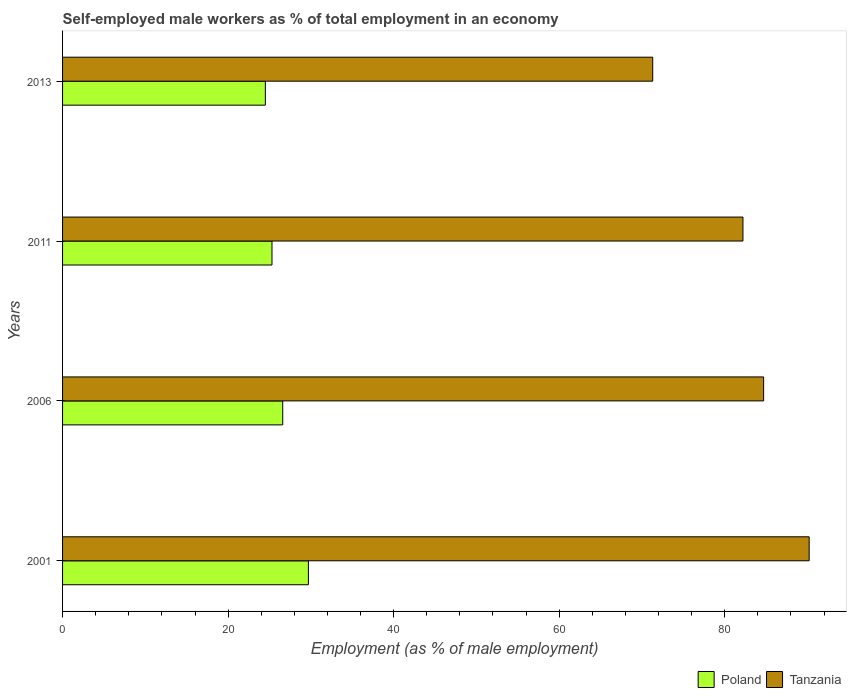Are the number of bars per tick equal to the number of legend labels?
Your answer should be compact. Yes. How many bars are there on the 4th tick from the bottom?
Give a very brief answer. 2. What is the percentage of self-employed male workers in Tanzania in 2011?
Make the answer very short. 82.2. Across all years, what is the maximum percentage of self-employed male workers in Poland?
Offer a very short reply. 29.7. Across all years, what is the minimum percentage of self-employed male workers in Poland?
Your answer should be compact. 24.5. In which year was the percentage of self-employed male workers in Poland maximum?
Provide a short and direct response. 2001. In which year was the percentage of self-employed male workers in Poland minimum?
Offer a very short reply. 2013. What is the total percentage of self-employed male workers in Poland in the graph?
Give a very brief answer. 106.1. What is the difference between the percentage of self-employed male workers in Poland in 2001 and that in 2006?
Give a very brief answer. 3.1. What is the difference between the percentage of self-employed male workers in Tanzania in 2006 and the percentage of self-employed male workers in Poland in 2011?
Offer a very short reply. 59.4. What is the average percentage of self-employed male workers in Tanzania per year?
Provide a short and direct response. 82.1. In the year 2013, what is the difference between the percentage of self-employed male workers in Tanzania and percentage of self-employed male workers in Poland?
Offer a very short reply. 46.8. In how many years, is the percentage of self-employed male workers in Tanzania greater than 56 %?
Your answer should be very brief. 4. What is the ratio of the percentage of self-employed male workers in Poland in 2006 to that in 2011?
Give a very brief answer. 1.05. Is the percentage of self-employed male workers in Tanzania in 2001 less than that in 2013?
Your answer should be very brief. No. What is the difference between the highest and the second highest percentage of self-employed male workers in Poland?
Your answer should be compact. 3.1. What is the difference between the highest and the lowest percentage of self-employed male workers in Poland?
Your answer should be very brief. 5.2. What does the 2nd bar from the top in 2013 represents?
Keep it short and to the point. Poland. How many bars are there?
Offer a terse response. 8. Are all the bars in the graph horizontal?
Keep it short and to the point. Yes. Are the values on the major ticks of X-axis written in scientific E-notation?
Your answer should be compact. No. Does the graph contain grids?
Ensure brevity in your answer.  No. Where does the legend appear in the graph?
Offer a very short reply. Bottom right. How are the legend labels stacked?
Provide a short and direct response. Horizontal. What is the title of the graph?
Provide a short and direct response. Self-employed male workers as % of total employment in an economy. What is the label or title of the X-axis?
Your answer should be compact. Employment (as % of male employment). What is the Employment (as % of male employment) in Poland in 2001?
Your response must be concise. 29.7. What is the Employment (as % of male employment) of Tanzania in 2001?
Your answer should be very brief. 90.2. What is the Employment (as % of male employment) of Poland in 2006?
Ensure brevity in your answer.  26.6. What is the Employment (as % of male employment) of Tanzania in 2006?
Ensure brevity in your answer.  84.7. What is the Employment (as % of male employment) of Poland in 2011?
Offer a very short reply. 25.3. What is the Employment (as % of male employment) in Tanzania in 2011?
Your response must be concise. 82.2. What is the Employment (as % of male employment) in Poland in 2013?
Offer a very short reply. 24.5. What is the Employment (as % of male employment) in Tanzania in 2013?
Keep it short and to the point. 71.3. Across all years, what is the maximum Employment (as % of male employment) of Poland?
Provide a short and direct response. 29.7. Across all years, what is the maximum Employment (as % of male employment) in Tanzania?
Your answer should be very brief. 90.2. Across all years, what is the minimum Employment (as % of male employment) in Tanzania?
Keep it short and to the point. 71.3. What is the total Employment (as % of male employment) of Poland in the graph?
Give a very brief answer. 106.1. What is the total Employment (as % of male employment) in Tanzania in the graph?
Offer a terse response. 328.4. What is the difference between the Employment (as % of male employment) of Tanzania in 2001 and that in 2006?
Offer a terse response. 5.5. What is the difference between the Employment (as % of male employment) in Poland in 2001 and that in 2011?
Offer a very short reply. 4.4. What is the difference between the Employment (as % of male employment) of Poland in 2001 and that in 2013?
Make the answer very short. 5.2. What is the difference between the Employment (as % of male employment) of Tanzania in 2001 and that in 2013?
Your answer should be compact. 18.9. What is the difference between the Employment (as % of male employment) of Poland in 2001 and the Employment (as % of male employment) of Tanzania in 2006?
Give a very brief answer. -55. What is the difference between the Employment (as % of male employment) of Poland in 2001 and the Employment (as % of male employment) of Tanzania in 2011?
Offer a very short reply. -52.5. What is the difference between the Employment (as % of male employment) of Poland in 2001 and the Employment (as % of male employment) of Tanzania in 2013?
Keep it short and to the point. -41.6. What is the difference between the Employment (as % of male employment) in Poland in 2006 and the Employment (as % of male employment) in Tanzania in 2011?
Keep it short and to the point. -55.6. What is the difference between the Employment (as % of male employment) of Poland in 2006 and the Employment (as % of male employment) of Tanzania in 2013?
Make the answer very short. -44.7. What is the difference between the Employment (as % of male employment) of Poland in 2011 and the Employment (as % of male employment) of Tanzania in 2013?
Your answer should be very brief. -46. What is the average Employment (as % of male employment) in Poland per year?
Provide a short and direct response. 26.52. What is the average Employment (as % of male employment) in Tanzania per year?
Your answer should be very brief. 82.1. In the year 2001, what is the difference between the Employment (as % of male employment) of Poland and Employment (as % of male employment) of Tanzania?
Provide a short and direct response. -60.5. In the year 2006, what is the difference between the Employment (as % of male employment) in Poland and Employment (as % of male employment) in Tanzania?
Your answer should be very brief. -58.1. In the year 2011, what is the difference between the Employment (as % of male employment) of Poland and Employment (as % of male employment) of Tanzania?
Your response must be concise. -56.9. In the year 2013, what is the difference between the Employment (as % of male employment) in Poland and Employment (as % of male employment) in Tanzania?
Offer a very short reply. -46.8. What is the ratio of the Employment (as % of male employment) in Poland in 2001 to that in 2006?
Offer a very short reply. 1.12. What is the ratio of the Employment (as % of male employment) of Tanzania in 2001 to that in 2006?
Provide a succinct answer. 1.06. What is the ratio of the Employment (as % of male employment) of Poland in 2001 to that in 2011?
Offer a very short reply. 1.17. What is the ratio of the Employment (as % of male employment) in Tanzania in 2001 to that in 2011?
Make the answer very short. 1.1. What is the ratio of the Employment (as % of male employment) of Poland in 2001 to that in 2013?
Make the answer very short. 1.21. What is the ratio of the Employment (as % of male employment) in Tanzania in 2001 to that in 2013?
Your answer should be very brief. 1.27. What is the ratio of the Employment (as % of male employment) of Poland in 2006 to that in 2011?
Keep it short and to the point. 1.05. What is the ratio of the Employment (as % of male employment) in Tanzania in 2006 to that in 2011?
Provide a short and direct response. 1.03. What is the ratio of the Employment (as % of male employment) of Poland in 2006 to that in 2013?
Provide a short and direct response. 1.09. What is the ratio of the Employment (as % of male employment) in Tanzania in 2006 to that in 2013?
Keep it short and to the point. 1.19. What is the ratio of the Employment (as % of male employment) in Poland in 2011 to that in 2013?
Keep it short and to the point. 1.03. What is the ratio of the Employment (as % of male employment) in Tanzania in 2011 to that in 2013?
Ensure brevity in your answer.  1.15. What is the difference between the highest and the second highest Employment (as % of male employment) in Tanzania?
Your response must be concise. 5.5. What is the difference between the highest and the lowest Employment (as % of male employment) of Poland?
Provide a short and direct response. 5.2. What is the difference between the highest and the lowest Employment (as % of male employment) in Tanzania?
Ensure brevity in your answer.  18.9. 